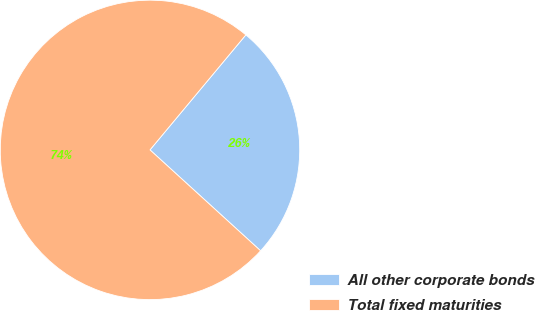Convert chart to OTSL. <chart><loc_0><loc_0><loc_500><loc_500><pie_chart><fcel>All other corporate bonds<fcel>Total fixed maturities<nl><fcel>25.71%<fcel>74.29%<nl></chart> 